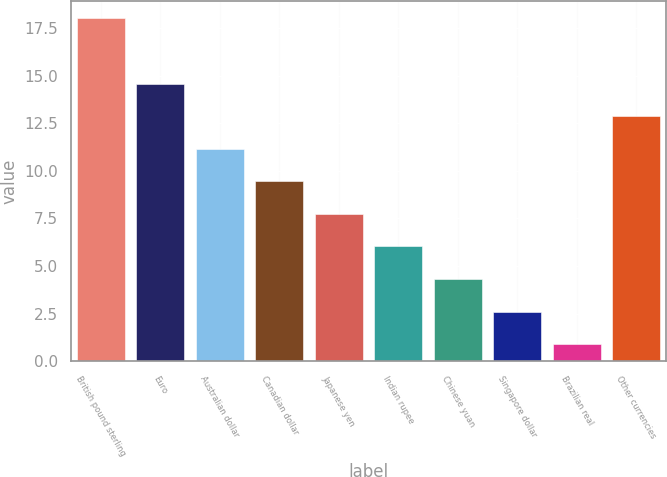<chart> <loc_0><loc_0><loc_500><loc_500><bar_chart><fcel>British pound sterling<fcel>Euro<fcel>Australian dollar<fcel>Canadian dollar<fcel>Japanese yen<fcel>Indian rupee<fcel>Chinese yuan<fcel>Singapore dollar<fcel>Brazilian real<fcel>Other currencies<nl><fcel>18<fcel>14.58<fcel>11.16<fcel>9.45<fcel>7.74<fcel>6.03<fcel>4.32<fcel>2.61<fcel>0.9<fcel>12.87<nl></chart> 